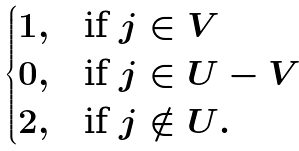Convert formula to latex. <formula><loc_0><loc_0><loc_500><loc_500>\begin{cases} 1 , & \text {if $j\in V$} \\ 0 , & \text {if $j\in U-V$} \\ 2 , & \text {if $j\notin U$} . \end{cases}</formula> 